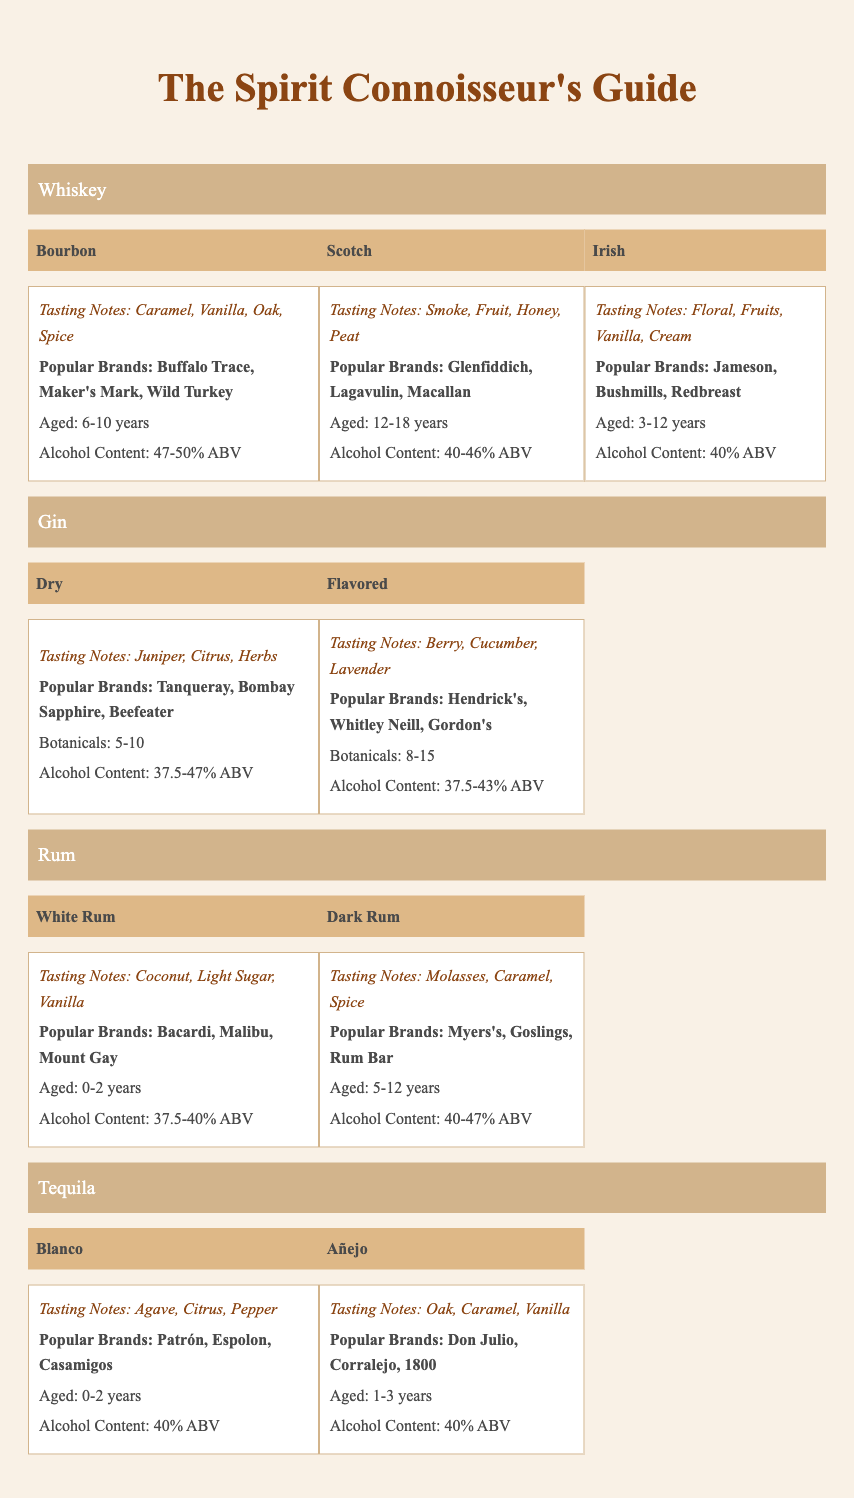What are the tasting notes for Bourbon? The table lists the tasting notes for Bourbon as "Caramel, Vanilla, Oak, Spice." This information is directly found in the section under the Bourbon type within the Whiskey category.
Answer: Caramel, Vanilla, Oak, Spice Which spirits have a recommended aging period of 1-3 years? The table shows that only Añejo Tequila has a recommended aging period of 1-3 years. It is found in the Tequila category, specifically under the Añejo type.
Answer: Añejo Tequila Is the Alcohol Content for all Whiskey types above 40% ABV? The table lists the Alcohol Content for Bourbon as "47-50% ABV," for Scotch as "40-46% ABV," and for Irish as "40% ABV." Since all values are equal to or greater than 40% ABV, the statement is true.
Answer: Yes What is the average Alcohol Content for Gin, Dry and Flavored types? The Alcohol Content for Dry Gin ranges from "37.5-47% ABV" and for Flavored Gin, it ranges from "37.5-43% ABV." To find an average, we take the midpoint of the ranges: Dry (42.25% ABV) and Flavored (40.25% ABV). The average is (42.25 + 40.25) / 2 = 41.25% ABV.
Answer: 41.25% ABV Which type of rum has the highest Alcohol Content? The table details that Dark Rum has a maximum Alcohol Content of "47% ABV," compared to White Rum, which has a maximum of "40% ABV." Therefore, Dark Rum has the highest Alcohol Content among the two types.
Answer: Dark Rum How many types of brands are listed under Irish Whiskey, and what are they? The table indicates that there are three brands under Irish Whiskey: "Jameson, Bushmills, Redbreast." This is explicitly found in the section for Irish Whiskey within the Whiskey category.
Answer: 3 brands: Jameson, Bushmills, Redbreast Is it true that flavored gin has more botanicals than dry gin? The table states that Flavored Gin has "8-15" botanicals, while Dry Gin has "5-10" botanicals. Since the maximum for Flavored Gin is greater than the maximum for Dry Gin, the statement is true.
Answer: Yes What are the unique tasting notes for Scotch compared to Bourbon? Scotch has unique tasting notes of "Smoke, Fruit, Honey, Peat," while Bourbon's notes are "Caramel, Vanilla, Oak, Spice." Comparing these lists shows that Scotch's tasting notes emphasize smoke and peat, which are not found in Bourbon.
Answer: Smoke, Fruit, Honey, Peat (unique to Scotch) 